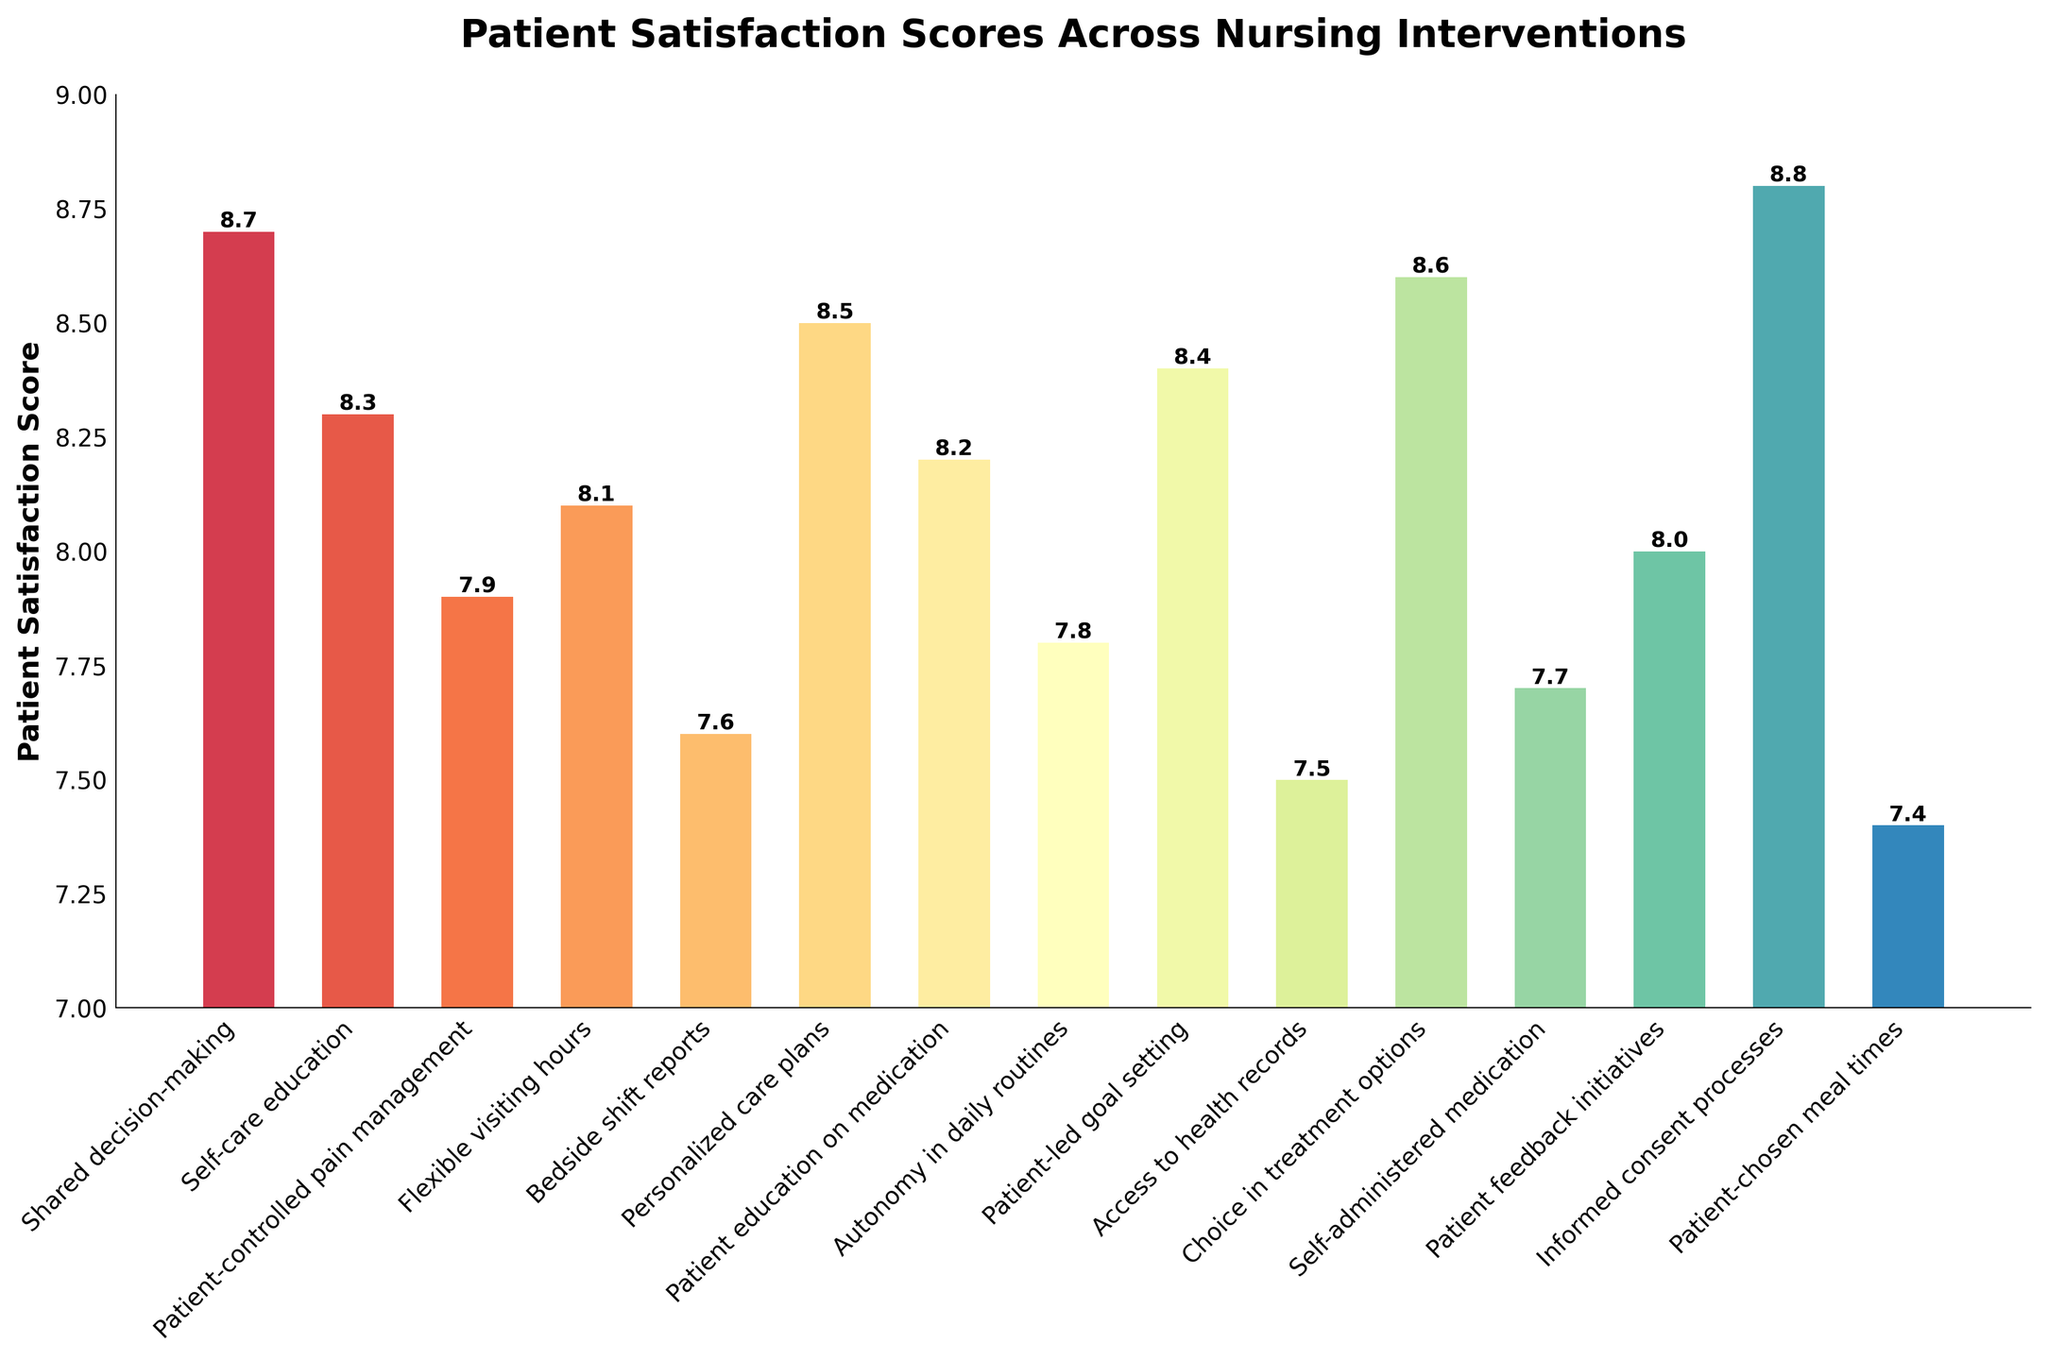Which nursing intervention has the highest patient satisfaction score? The bar for "Informed consent processes" is the tallest, indicating the highest patient satisfaction score.
Answer: Informed consent processes What is the difference in patient satisfaction scores between "Shared decision-making" and "Access to health records"? The patient satisfaction score for "Shared decision-making" is 8.7 and for "Access to health records" is 7.5, the difference is 8.7 - 7.5.
Answer: 1.2 Which interventions have a satisfaction score greater than or equal to 8.5? The bars with heights 8.5 or above are "Shared decision-making" (8.7), "Personalized care plans" (8.5), "Choice in treatment options" (8.6), and "Informed consent processes" (8.8).
Answer: Shared decision-making, Personalized care plans, Choice in treatment options, Informed consent processes What is the total sum of the patient satisfaction scores for "Patient-controlled pain management" and "Flexible visiting hours"? The scores are 7.9 and 8.1, so the sum is 7.9 + 8.1.
Answer: 16.0 Which intervention has the lowest satisfaction score? The bar for "Patient-chosen meal times" is the shortest, indicating the lowest patient satisfaction score.
Answer: Patient-chosen meal times By how much does the satisfaction score for "Patient feedback initiatives" exceed that of "Self-administered medication"? The scores are 8.0 for "Patient feedback initiatives" and 7.7 for "Self-administered medication," so the difference is 8.0 - 7.7.
Answer: 0.3 Which interventions have scores below the mean satisfaction score? First, calculate the mean: \( \frac{8.7 + 8.3 + 7.9 + 8.1 + 7.6 + 8.5 + 8.2 + 7.8 + 8.4 + 7.5 + 8.6 + 7.7 + 8.0 + 8.8 + 7.4}{15} = 8.1 \). Interventions below 8.1 are "Patient-controlled pain management," "Bedside shift reports," "Autonomy in daily routines," "Access to health records," and "Patient-chosen meal times."
Answer: Patient-controlled pain management, Bedside shift reports, Autonomy in daily routines, Access to health records, Patient-chosen meal times What is the average satisfaction score for the interventions "Self-care education", "Bedside shift reports", and "Patient education on medication"? Sum up the scores for these interventions: 8.3 (Self-care education) + 7.6 (Bedside shift reports) + 8.2 (Patient education on medication) = 24.1. The average is 24.1 / 3.
Answer: 8.03 